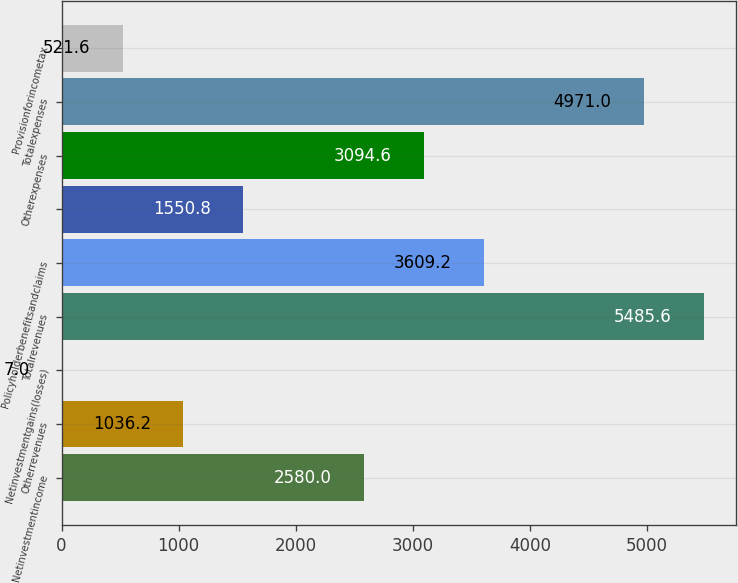<chart> <loc_0><loc_0><loc_500><loc_500><bar_chart><fcel>Netinvestmentincome<fcel>Otherrevenues<fcel>Netinvestmentgains(losses)<fcel>Totalrevenues<fcel>Policyholderbenefitsandclaims<fcel>Unnamed: 5<fcel>Otherexpenses<fcel>Totalexpenses<fcel>Provisionforincometax<nl><fcel>2580<fcel>1036.2<fcel>7<fcel>5485.6<fcel>3609.2<fcel>1550.8<fcel>3094.6<fcel>4971<fcel>521.6<nl></chart> 